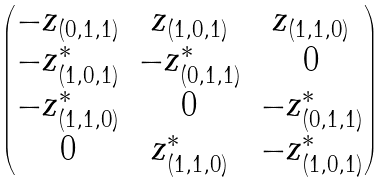<formula> <loc_0><loc_0><loc_500><loc_500>\begin{pmatrix} - z _ { ( 0 , 1 , 1 ) } & z _ { ( 1 , 0 , 1 ) } & z _ { ( 1 , 1 , 0 ) } \\ - z ^ { * } _ { ( 1 , 0 , 1 ) } & - z ^ { * } _ { ( 0 , 1 , 1 ) } & 0 \\ - z ^ { * } _ { ( 1 , 1 , 0 ) } & 0 & - z ^ { * } _ { ( 0 , 1 , 1 ) } \\ 0 & z ^ { * } _ { ( 1 , 1 , 0 ) } & - z ^ { * } _ { ( 1 , 0 , 1 ) } \end{pmatrix}</formula> 